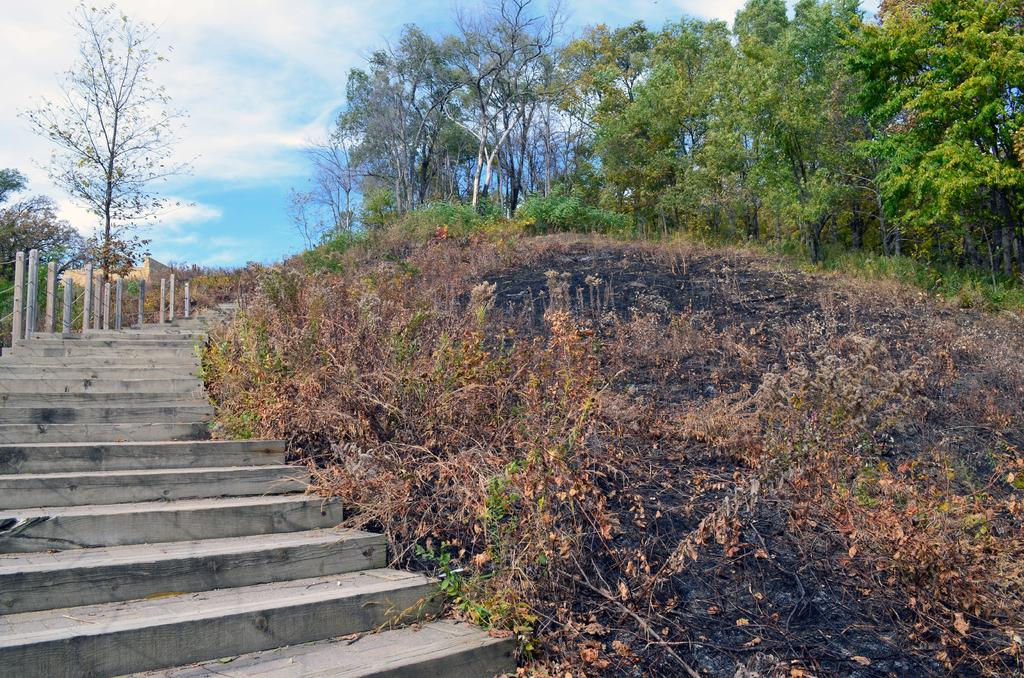What type of structure is present in the image? There are stairs in the image. What can be seen on the left side of the image? There is a boundary on the left side of the image. What type of environment is depicted in the image? There is greenery visible in the image. How does the scarecrow control the corn in the image? There is no scarecrow or corn present in the image. 